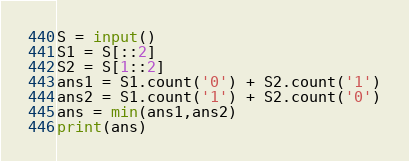Convert code to text. <code><loc_0><loc_0><loc_500><loc_500><_Python_>S = input()
S1 = S[::2]
S2 = S[1::2]
ans1 = S1.count('0') + S2.count('1')
ans2 = S1.count('1') + S2.count('0')
ans = min(ans1,ans2)
print(ans)</code> 